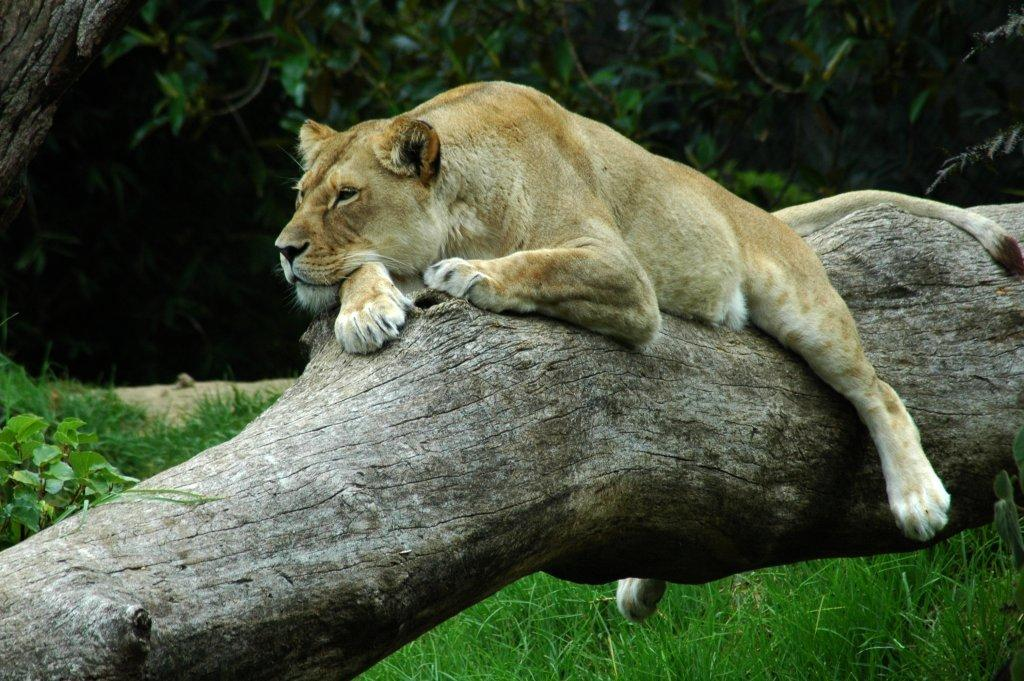What animal is the main subject of the image? There is a tiger in the image. Where is the tiger located? The tiger is on a tree trunk. What can be seen in the background of the image? There are trees visible in the background of the image. What type of current can be seen flowing through the tiger's fur in the image? There is no current visible in the image, as it features a tiger on a tree trunk with no water or flowing substances present. 